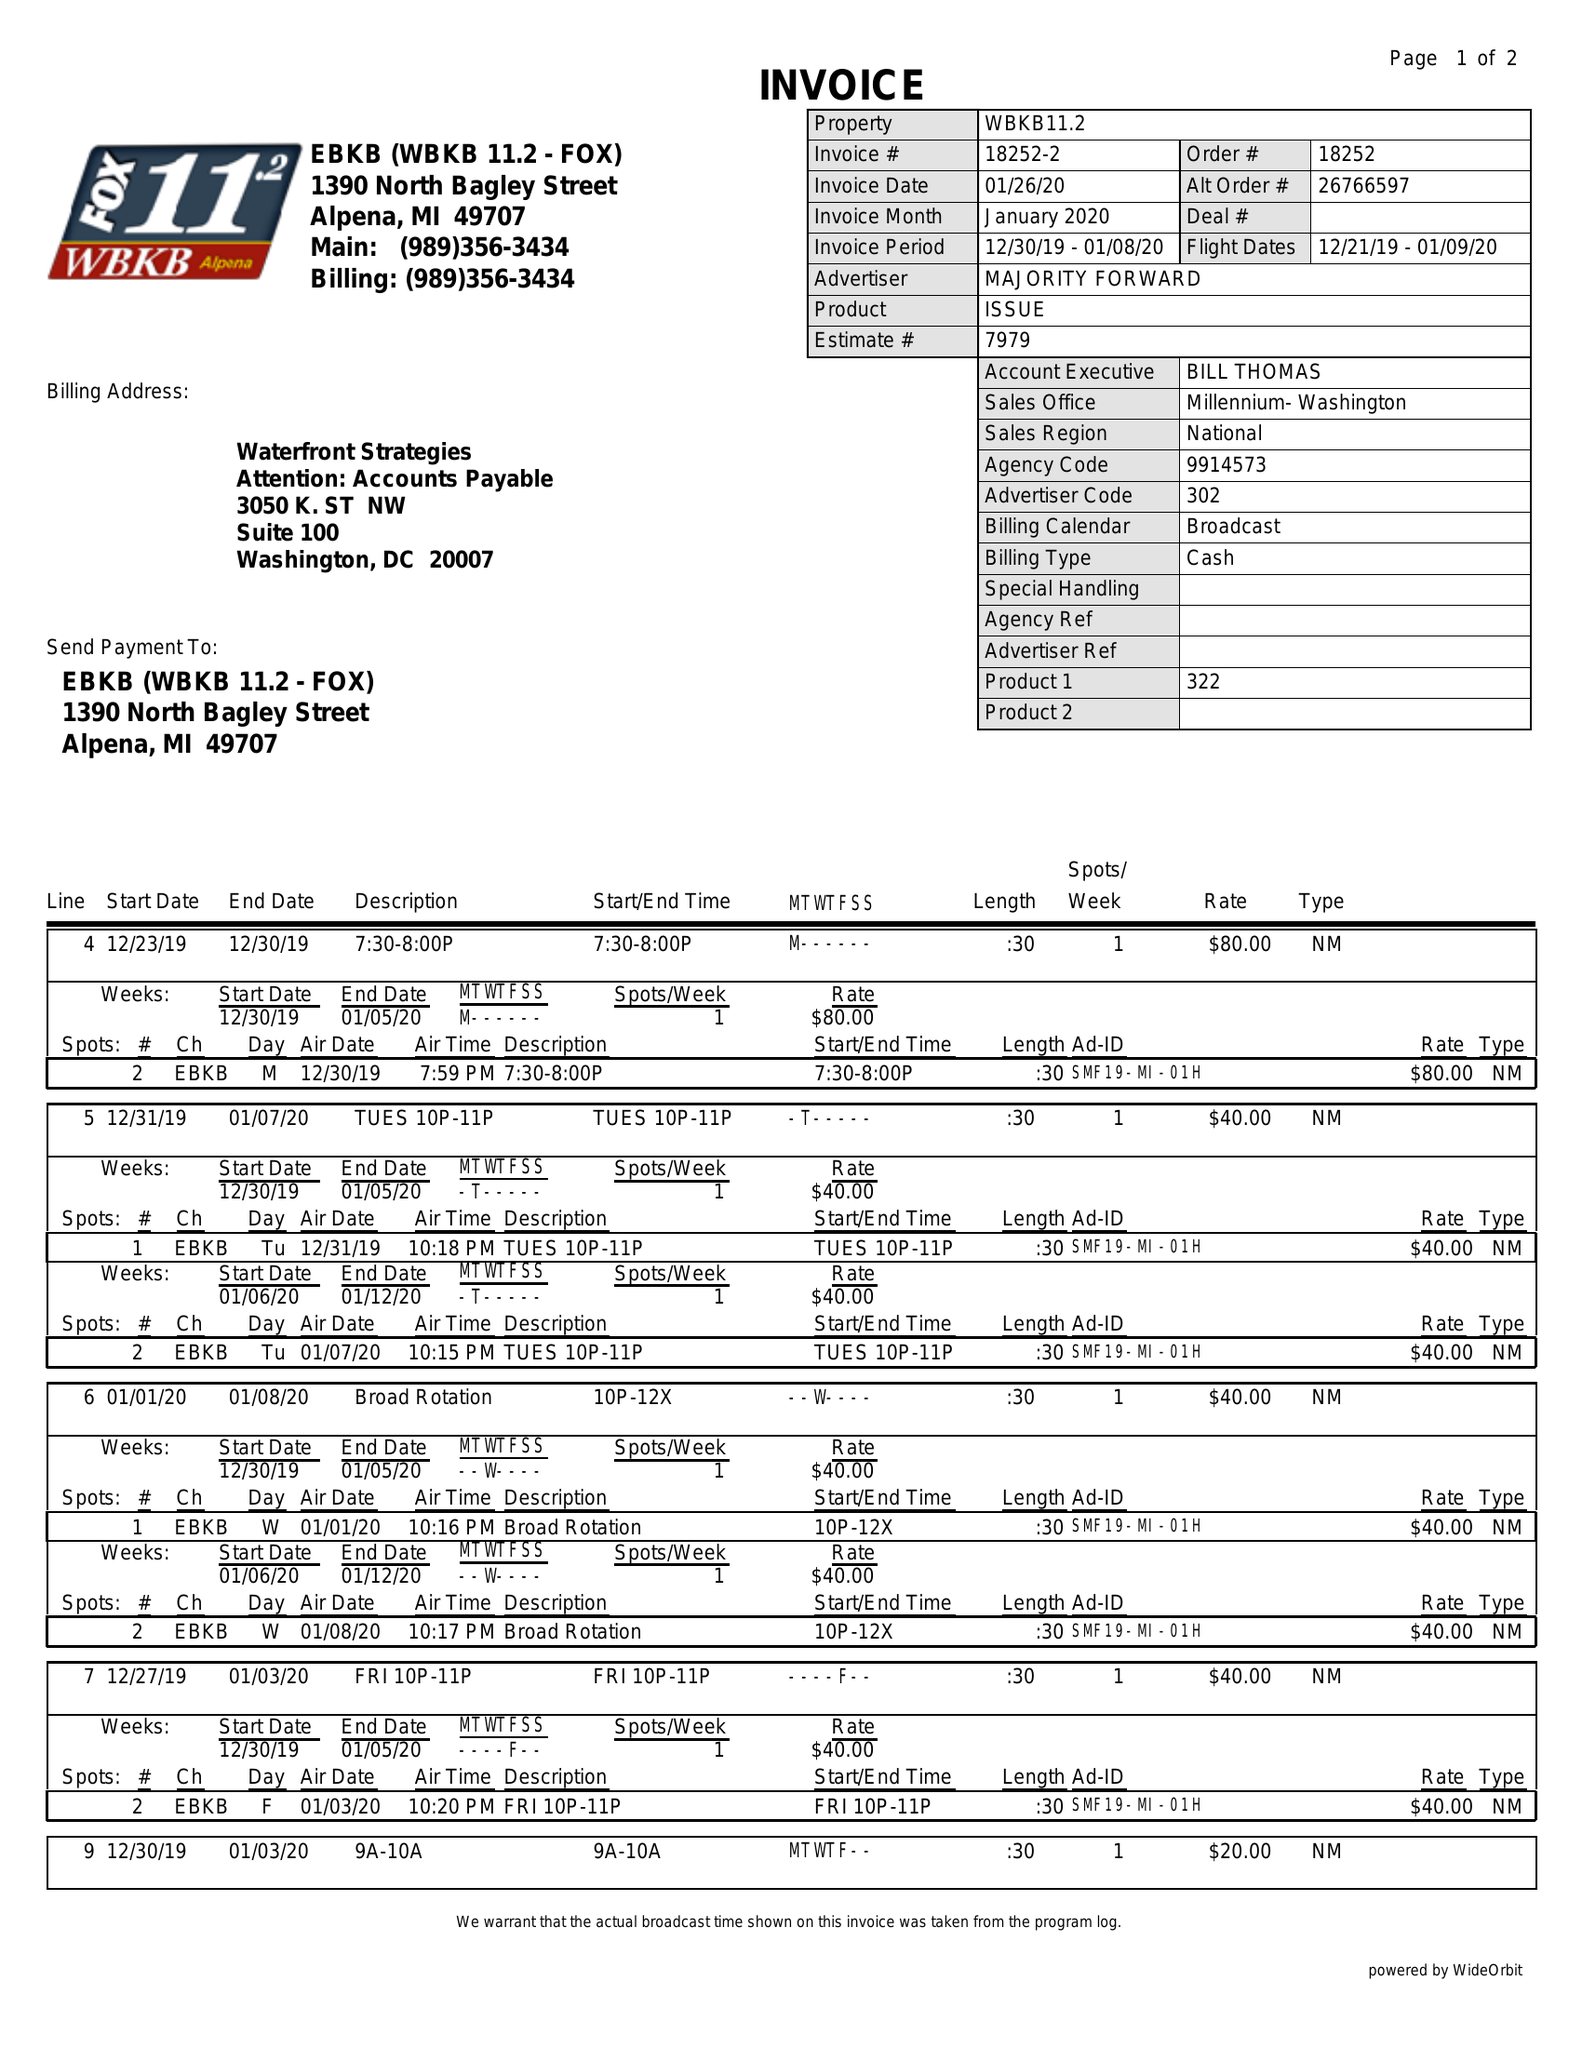What is the value for the flight_to?
Answer the question using a single word or phrase. 01/09/20 